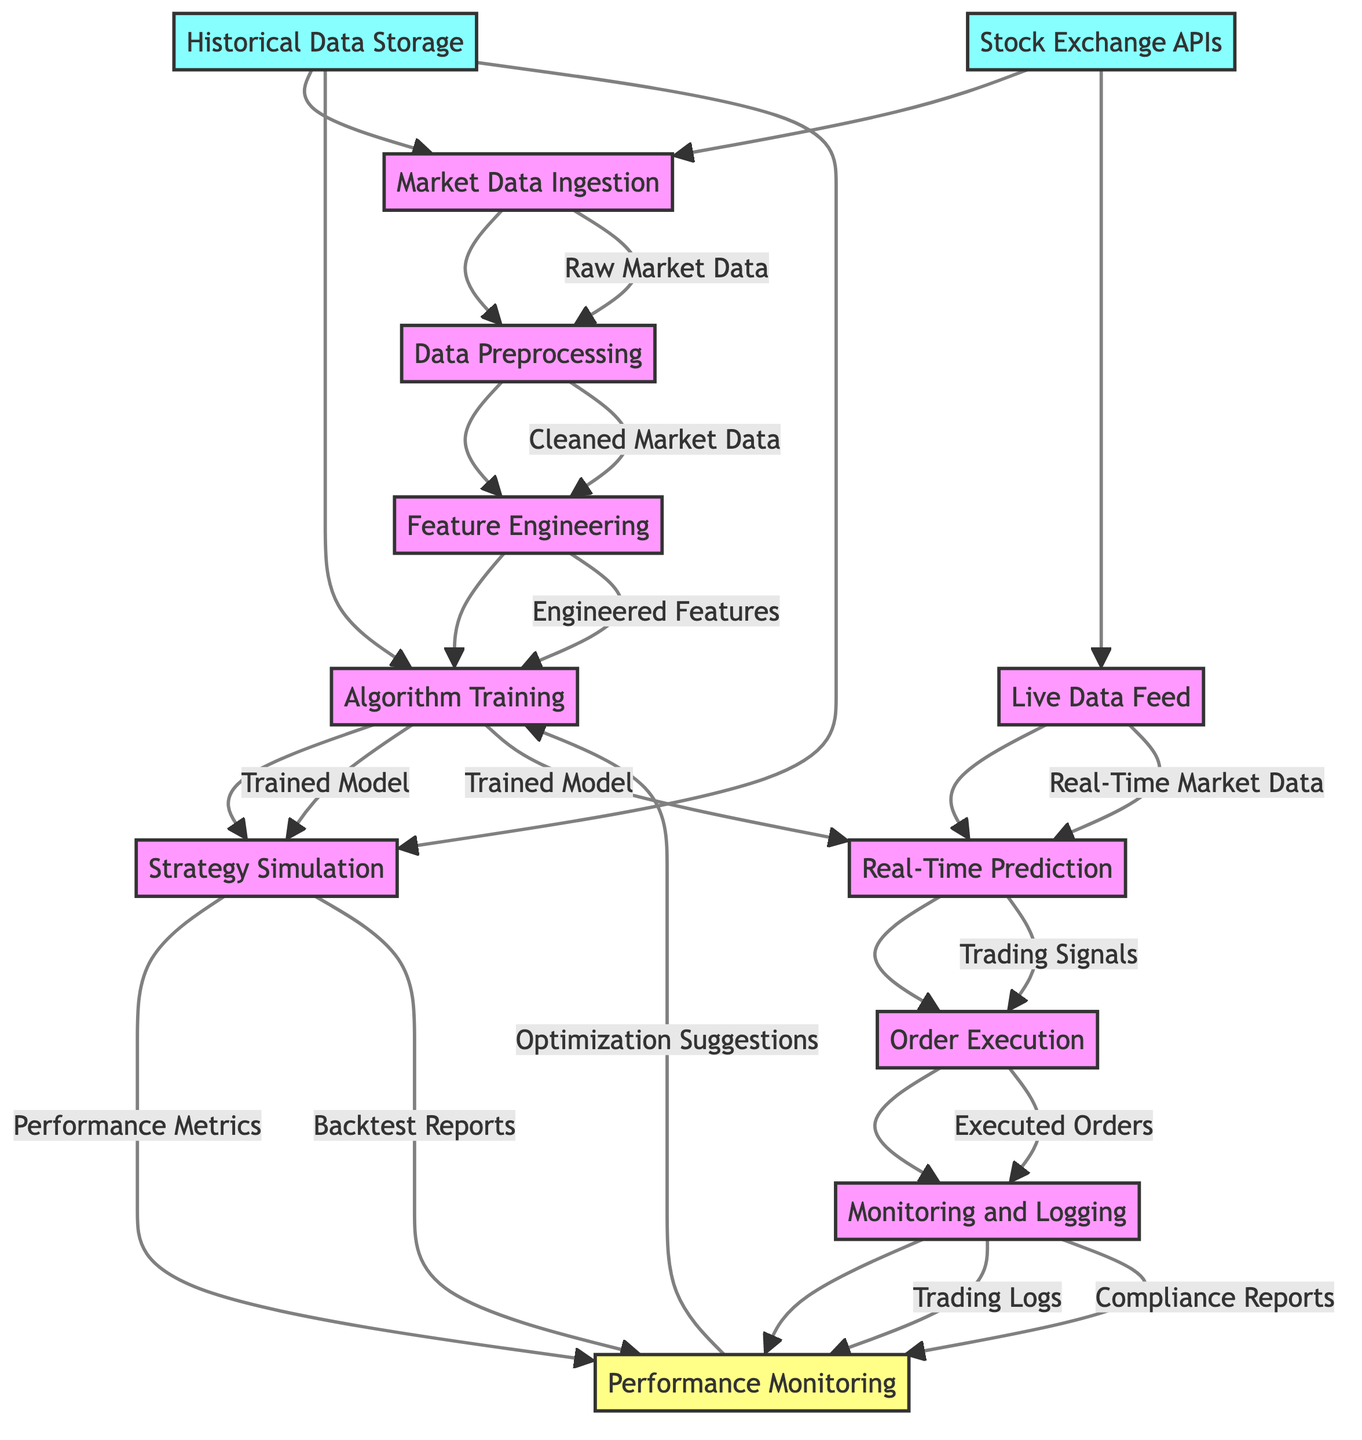What is the first step in the automated stock trading algorithm workflow? The first step in the workflow, as indicated in the diagram, is "Market Data Ingestion," which collects real-time stock market data.
Answer: Market Data Ingestion Which element produces "Cleaned Market Data"? "Data Preprocessing" is the element that takes "Raw Market Data" as input and outputs "Cleaned Market Data."
Answer: Data Preprocessing How many outputs does the "Strategy Simulation" element produce? The "Strategy Simulation (Backtesting)" produces two outputs: "Performance Metrics" and "Backtest Reports," as shown in the diagram.
Answer: 2 What is the relationship between "Real-Time Prediction" and "Order Execution"? "Real-Time Prediction" outputs "Trading Signals," which then serve as input for "Order Execution," indicating a direct flow between these two elements.
Answer: Trading Signals Which input does both "Market Data Ingestion" and "Live Data Feed" share? Both elements utilize "Stock Exchange APIs" as their input for collecting market data.
Answer: Stock Exchange APIs What happens after the "Order Execution" step? After the "Order Execution," the next step is "Monitoring and Logging," which monitors trading activities and logs transactions for future analysis.
Answer: Monitoring and Logging How does the "Performance Monitoring" step utilize its inputs? "Performance Monitoring" takes in "Trading Logs" and "Performance Metrics" to generate "Optimization Suggestions," leveraging both elements to improve the algorithm.
Answer: Optimization Suggestions What type of output is included from the "Monitoring and Logging" process? The "Monitoring and Logging" process produces two outputs: "Trading Logs" and "Compliance Reports," which are essential for analysis and compliance reporting.
Answer: Trading Logs, Compliance Reports What is the final output of this workflow? The final output of the workflow is "Optimization Suggestions," which are derived from continuous performance monitoring and aimed at refining the trading model.
Answer: Optimization Suggestions 